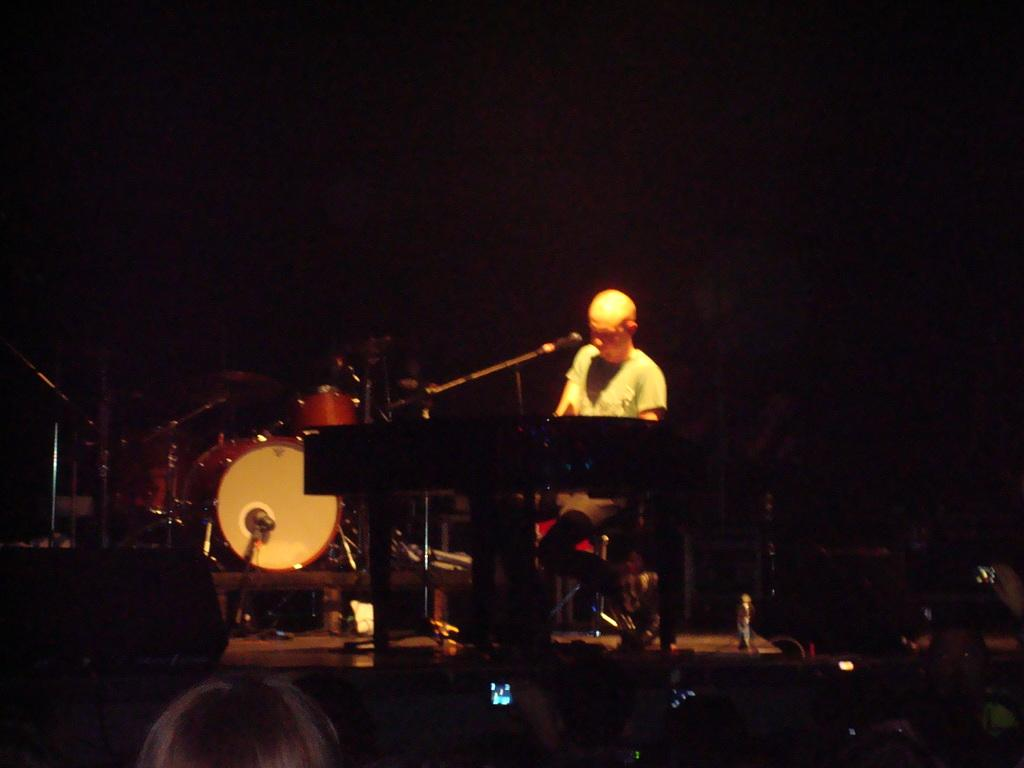What is the main subject of the image? There is a person in the image. What is the person doing in the image? The person is playing a musical instrument. Can you describe the person's position in relation to another object in the image? The person is in front of a microphone. What other musical instruments can be seen in the image? There are drums visible in the image. How does the person in the image sort the different types of growth? There is no mention of growth or sorting in the image; the focus is on the person playing a musical instrument and their position in relation to a microphone and drums. 